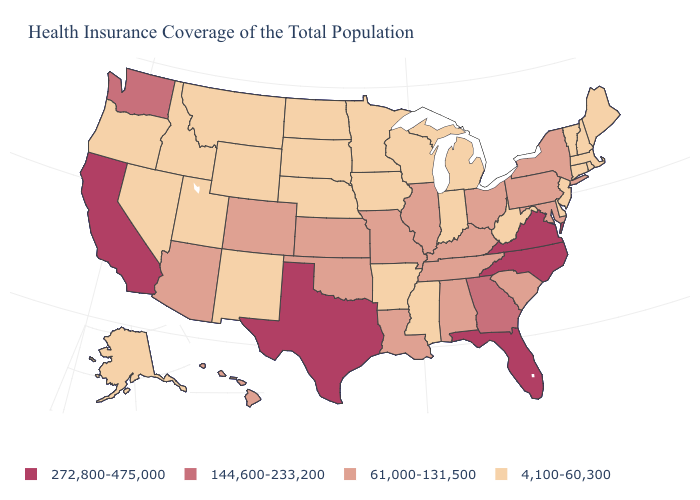Is the legend a continuous bar?
Write a very short answer. No. What is the highest value in the USA?
Quick response, please. 272,800-475,000. How many symbols are there in the legend?
Short answer required. 4. Among the states that border Washington , which have the lowest value?
Be succinct. Idaho, Oregon. Which states have the lowest value in the USA?
Answer briefly. Alaska, Arkansas, Connecticut, Delaware, Idaho, Indiana, Iowa, Maine, Massachusetts, Michigan, Minnesota, Mississippi, Montana, Nebraska, Nevada, New Hampshire, New Jersey, New Mexico, North Dakota, Oregon, Rhode Island, South Dakota, Utah, Vermont, West Virginia, Wisconsin, Wyoming. What is the value of Illinois?
Concise answer only. 61,000-131,500. Does South Dakota have the lowest value in the MidWest?
Give a very brief answer. Yes. Which states have the lowest value in the USA?
Write a very short answer. Alaska, Arkansas, Connecticut, Delaware, Idaho, Indiana, Iowa, Maine, Massachusetts, Michigan, Minnesota, Mississippi, Montana, Nebraska, Nevada, New Hampshire, New Jersey, New Mexico, North Dakota, Oregon, Rhode Island, South Dakota, Utah, Vermont, West Virginia, Wisconsin, Wyoming. Name the states that have a value in the range 61,000-131,500?
Quick response, please. Alabama, Arizona, Colorado, Hawaii, Illinois, Kansas, Kentucky, Louisiana, Maryland, Missouri, New York, Ohio, Oklahoma, Pennsylvania, South Carolina, Tennessee. Does Arkansas have the highest value in the USA?
Short answer required. No. What is the value of Massachusetts?
Answer briefly. 4,100-60,300. Does Ohio have a lower value than Washington?
Answer briefly. Yes. What is the lowest value in states that border Oklahoma?
Short answer required. 4,100-60,300. What is the value of Indiana?
Short answer required. 4,100-60,300. What is the highest value in states that border Nebraska?
Give a very brief answer. 61,000-131,500. 